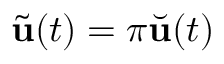Convert formula to latex. <formula><loc_0><loc_0><loc_500><loc_500>\tilde { u } ( t ) = \pi \breve { u } ( t )</formula> 